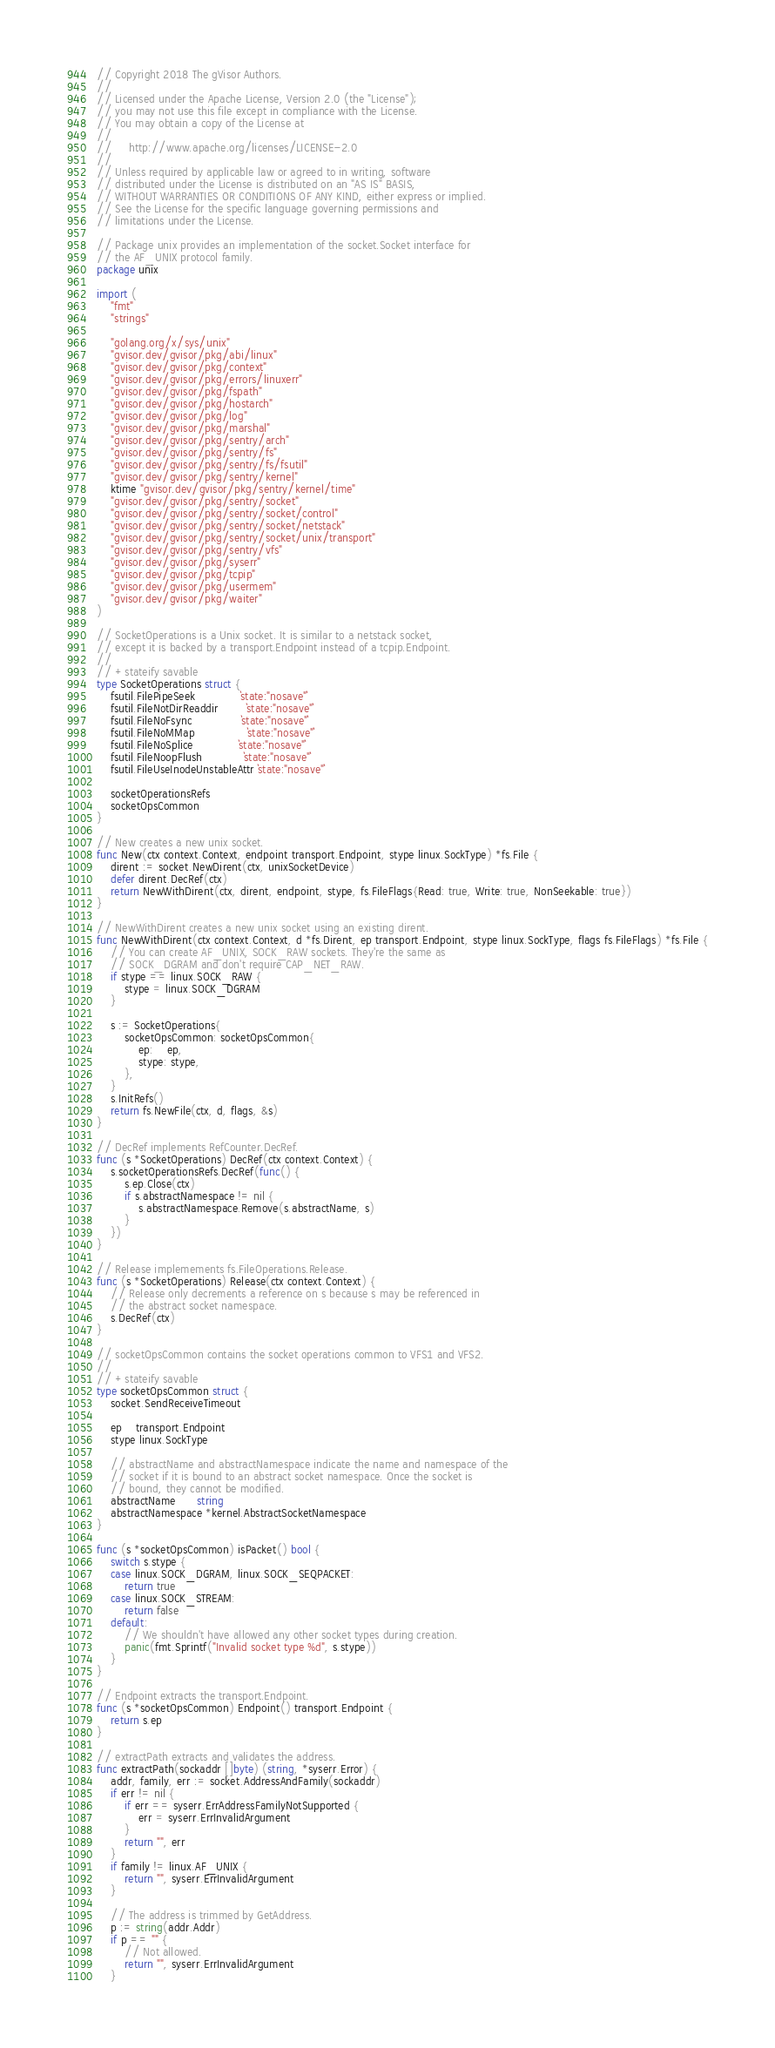Convert code to text. <code><loc_0><loc_0><loc_500><loc_500><_Go_>// Copyright 2018 The gVisor Authors.
//
// Licensed under the Apache License, Version 2.0 (the "License");
// you may not use this file except in compliance with the License.
// You may obtain a copy of the License at
//
//     http://www.apache.org/licenses/LICENSE-2.0
//
// Unless required by applicable law or agreed to in writing, software
// distributed under the License is distributed on an "AS IS" BASIS,
// WITHOUT WARRANTIES OR CONDITIONS OF ANY KIND, either express or implied.
// See the License for the specific language governing permissions and
// limitations under the License.

// Package unix provides an implementation of the socket.Socket interface for
// the AF_UNIX protocol family.
package unix

import (
	"fmt"
	"strings"

	"golang.org/x/sys/unix"
	"gvisor.dev/gvisor/pkg/abi/linux"
	"gvisor.dev/gvisor/pkg/context"
	"gvisor.dev/gvisor/pkg/errors/linuxerr"
	"gvisor.dev/gvisor/pkg/fspath"
	"gvisor.dev/gvisor/pkg/hostarch"
	"gvisor.dev/gvisor/pkg/log"
	"gvisor.dev/gvisor/pkg/marshal"
	"gvisor.dev/gvisor/pkg/sentry/arch"
	"gvisor.dev/gvisor/pkg/sentry/fs"
	"gvisor.dev/gvisor/pkg/sentry/fs/fsutil"
	"gvisor.dev/gvisor/pkg/sentry/kernel"
	ktime "gvisor.dev/gvisor/pkg/sentry/kernel/time"
	"gvisor.dev/gvisor/pkg/sentry/socket"
	"gvisor.dev/gvisor/pkg/sentry/socket/control"
	"gvisor.dev/gvisor/pkg/sentry/socket/netstack"
	"gvisor.dev/gvisor/pkg/sentry/socket/unix/transport"
	"gvisor.dev/gvisor/pkg/sentry/vfs"
	"gvisor.dev/gvisor/pkg/syserr"
	"gvisor.dev/gvisor/pkg/tcpip"
	"gvisor.dev/gvisor/pkg/usermem"
	"gvisor.dev/gvisor/pkg/waiter"
)

// SocketOperations is a Unix socket. It is similar to a netstack socket,
// except it is backed by a transport.Endpoint instead of a tcpip.Endpoint.
//
// +stateify savable
type SocketOperations struct {
	fsutil.FilePipeSeek             `state:"nosave"`
	fsutil.FileNotDirReaddir        `state:"nosave"`
	fsutil.FileNoFsync              `state:"nosave"`
	fsutil.FileNoMMap               `state:"nosave"`
	fsutil.FileNoSplice             `state:"nosave"`
	fsutil.FileNoopFlush            `state:"nosave"`
	fsutil.FileUseInodeUnstableAttr `state:"nosave"`

	socketOperationsRefs
	socketOpsCommon
}

// New creates a new unix socket.
func New(ctx context.Context, endpoint transport.Endpoint, stype linux.SockType) *fs.File {
	dirent := socket.NewDirent(ctx, unixSocketDevice)
	defer dirent.DecRef(ctx)
	return NewWithDirent(ctx, dirent, endpoint, stype, fs.FileFlags{Read: true, Write: true, NonSeekable: true})
}

// NewWithDirent creates a new unix socket using an existing dirent.
func NewWithDirent(ctx context.Context, d *fs.Dirent, ep transport.Endpoint, stype linux.SockType, flags fs.FileFlags) *fs.File {
	// You can create AF_UNIX, SOCK_RAW sockets. They're the same as
	// SOCK_DGRAM and don't require CAP_NET_RAW.
	if stype == linux.SOCK_RAW {
		stype = linux.SOCK_DGRAM
	}

	s := SocketOperations{
		socketOpsCommon: socketOpsCommon{
			ep:    ep,
			stype: stype,
		},
	}
	s.InitRefs()
	return fs.NewFile(ctx, d, flags, &s)
}

// DecRef implements RefCounter.DecRef.
func (s *SocketOperations) DecRef(ctx context.Context) {
	s.socketOperationsRefs.DecRef(func() {
		s.ep.Close(ctx)
		if s.abstractNamespace != nil {
			s.abstractNamespace.Remove(s.abstractName, s)
		}
	})
}

// Release implemements fs.FileOperations.Release.
func (s *SocketOperations) Release(ctx context.Context) {
	// Release only decrements a reference on s because s may be referenced in
	// the abstract socket namespace.
	s.DecRef(ctx)
}

// socketOpsCommon contains the socket operations common to VFS1 and VFS2.
//
// +stateify savable
type socketOpsCommon struct {
	socket.SendReceiveTimeout

	ep    transport.Endpoint
	stype linux.SockType

	// abstractName and abstractNamespace indicate the name and namespace of the
	// socket if it is bound to an abstract socket namespace. Once the socket is
	// bound, they cannot be modified.
	abstractName      string
	abstractNamespace *kernel.AbstractSocketNamespace
}

func (s *socketOpsCommon) isPacket() bool {
	switch s.stype {
	case linux.SOCK_DGRAM, linux.SOCK_SEQPACKET:
		return true
	case linux.SOCK_STREAM:
		return false
	default:
		// We shouldn't have allowed any other socket types during creation.
		panic(fmt.Sprintf("Invalid socket type %d", s.stype))
	}
}

// Endpoint extracts the transport.Endpoint.
func (s *socketOpsCommon) Endpoint() transport.Endpoint {
	return s.ep
}

// extractPath extracts and validates the address.
func extractPath(sockaddr []byte) (string, *syserr.Error) {
	addr, family, err := socket.AddressAndFamily(sockaddr)
	if err != nil {
		if err == syserr.ErrAddressFamilyNotSupported {
			err = syserr.ErrInvalidArgument
		}
		return "", err
	}
	if family != linux.AF_UNIX {
		return "", syserr.ErrInvalidArgument
	}

	// The address is trimmed by GetAddress.
	p := string(addr.Addr)
	if p == "" {
		// Not allowed.
		return "", syserr.ErrInvalidArgument
	}</code> 